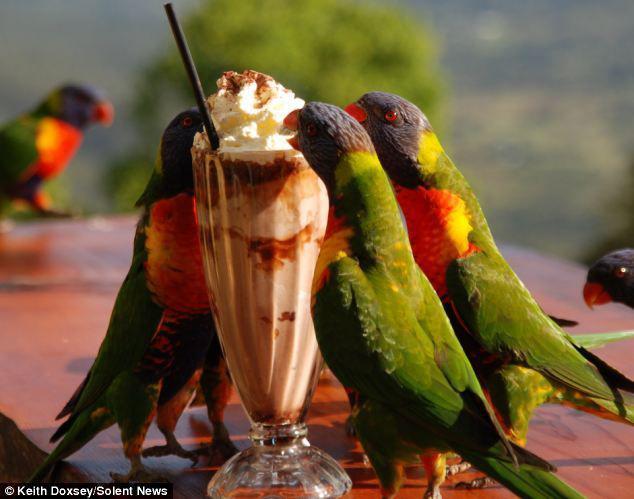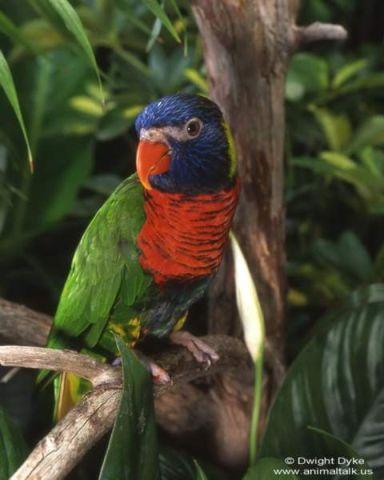The first image is the image on the left, the second image is the image on the right. For the images shown, is this caption "At least one image shows a group of parrots around some kind of round container for food or drink." true? Answer yes or no. Yes. The first image is the image on the left, the second image is the image on the right. Analyze the images presented: Is the assertion "All green parrots have orange chest areas." valid? Answer yes or no. Yes. The first image is the image on the left, the second image is the image on the right. Assess this claim about the two images: "There are exactly two birds in one of the images.". Correct or not? Answer yes or no. No. The first image is the image on the left, the second image is the image on the right. Analyze the images presented: Is the assertion "A single bird perches on a branch outside in one of the images." valid? Answer yes or no. Yes. 